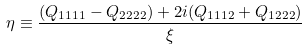Convert formula to latex. <formula><loc_0><loc_0><loc_500><loc_500>\eta \equiv \frac { ( Q _ { 1 1 1 1 } - Q _ { 2 2 2 2 } ) + 2 i ( Q _ { 1 1 1 2 } + Q _ { 1 2 2 2 } ) } { \xi }</formula> 